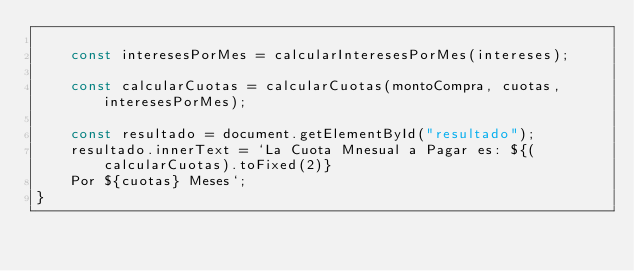Convert code to text. <code><loc_0><loc_0><loc_500><loc_500><_JavaScript_>
    const interesesPorMes = calcularInteresesPorMes(intereses);

    const calcularCuotas = calcularCuotas(montoCompra, cuotas, interesesPorMes);

    const resultado = document.getElementById("resultado");
    resultado.innerText = `La Cuota Mnesual a Pagar es: ${(calcularCuotas).toFixed(2)}
    Por ${cuotas} Meses`;
}</code> 